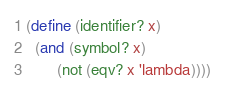<code> <loc_0><loc_0><loc_500><loc_500><_Scheme_>(define (identifier? x)
  (and (symbol? x)
       (not (eqv? x 'lambda))))
</code> 